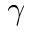<formula> <loc_0><loc_0><loc_500><loc_500>\gamma</formula> 